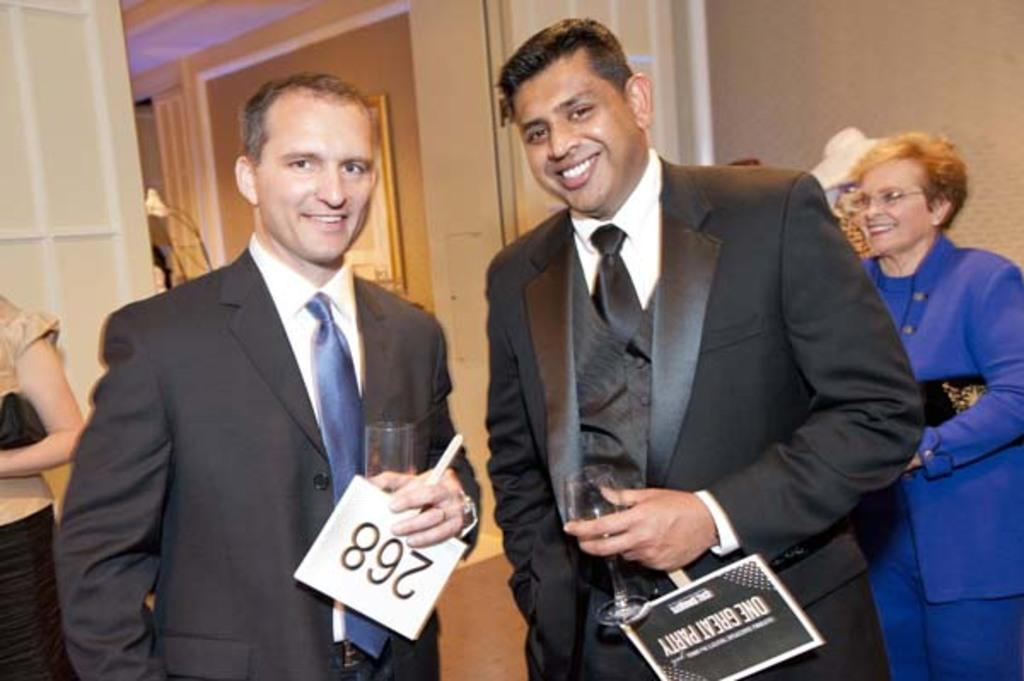What can be seen in the image involving people? There are people standing in the image. What architectural feature is present in the image? There is a door in the image. What other element can be seen in the image related to architecture? There is a wall in the image. What type of teeth can be seen on the people in the image? There is no mention of teeth in the image, as it only features people standing and architectural elements. 